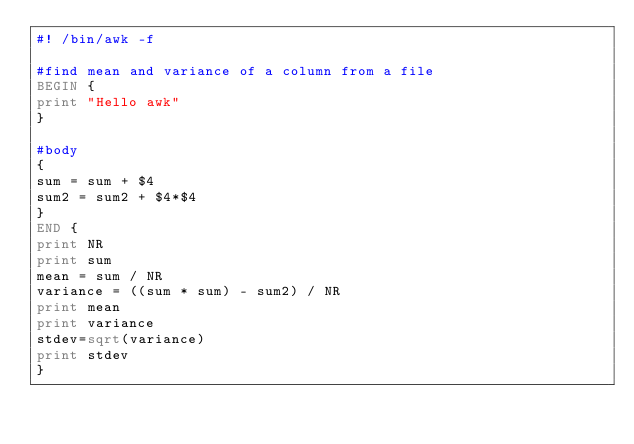Convert code to text. <code><loc_0><loc_0><loc_500><loc_500><_Awk_>#! /bin/awk -f

#find mean and variance of a column from a file
BEGIN {
print "Hello awk"
}

#body
{
sum = sum + $4
sum2 = sum2 + $4*$4
}
END { 
print NR
print sum 
mean = sum / NR
variance = ((sum * sum) - sum2) / NR
print mean
print variance
stdev=sqrt(variance)
print stdev
}
</code> 